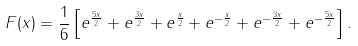<formula> <loc_0><loc_0><loc_500><loc_500>F ( x ) = \frac { 1 } { 6 } \left [ e ^ { \frac { 5 x } { 2 } } + e ^ { \frac { 3 x } { 2 } } + e ^ { \frac { x } { 2 } } + e ^ { - \frac { x } { 2 } } + e ^ { - \frac { 3 x } { 2 } } + e ^ { - \frac { 5 x } { 2 } } \right ] .</formula> 